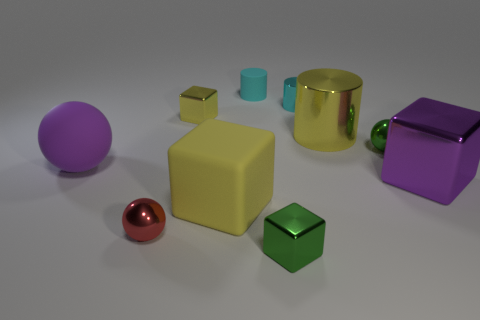Subtract all green cylinders. How many yellow cubes are left? 2 Subtract all big purple cubes. How many cubes are left? 3 Subtract all purple blocks. How many blocks are left? 3 Subtract 1 cylinders. How many cylinders are left? 2 Subtract all spheres. How many objects are left? 7 Subtract all red blocks. Subtract all gray balls. How many blocks are left? 4 Add 9 gray matte cylinders. How many gray matte cylinders exist? 9 Subtract 0 cyan spheres. How many objects are left? 10 Subtract all matte objects. Subtract all green objects. How many objects are left? 5 Add 1 big yellow objects. How many big yellow objects are left? 3 